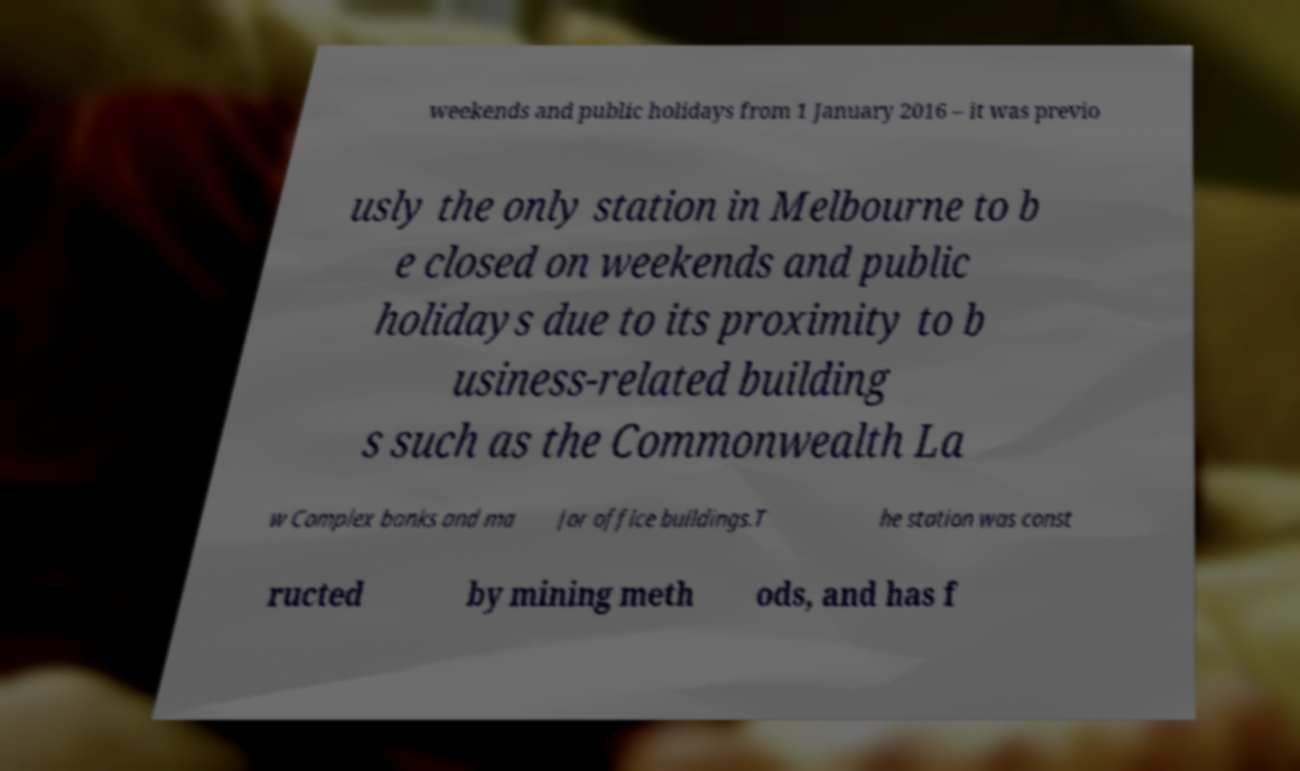Please read and relay the text visible in this image. What does it say? weekends and public holidays from 1 January 2016 – it was previo usly the only station in Melbourne to b e closed on weekends and public holidays due to its proximity to b usiness-related building s such as the Commonwealth La w Complex banks and ma jor office buildings.T he station was const ructed by mining meth ods, and has f 